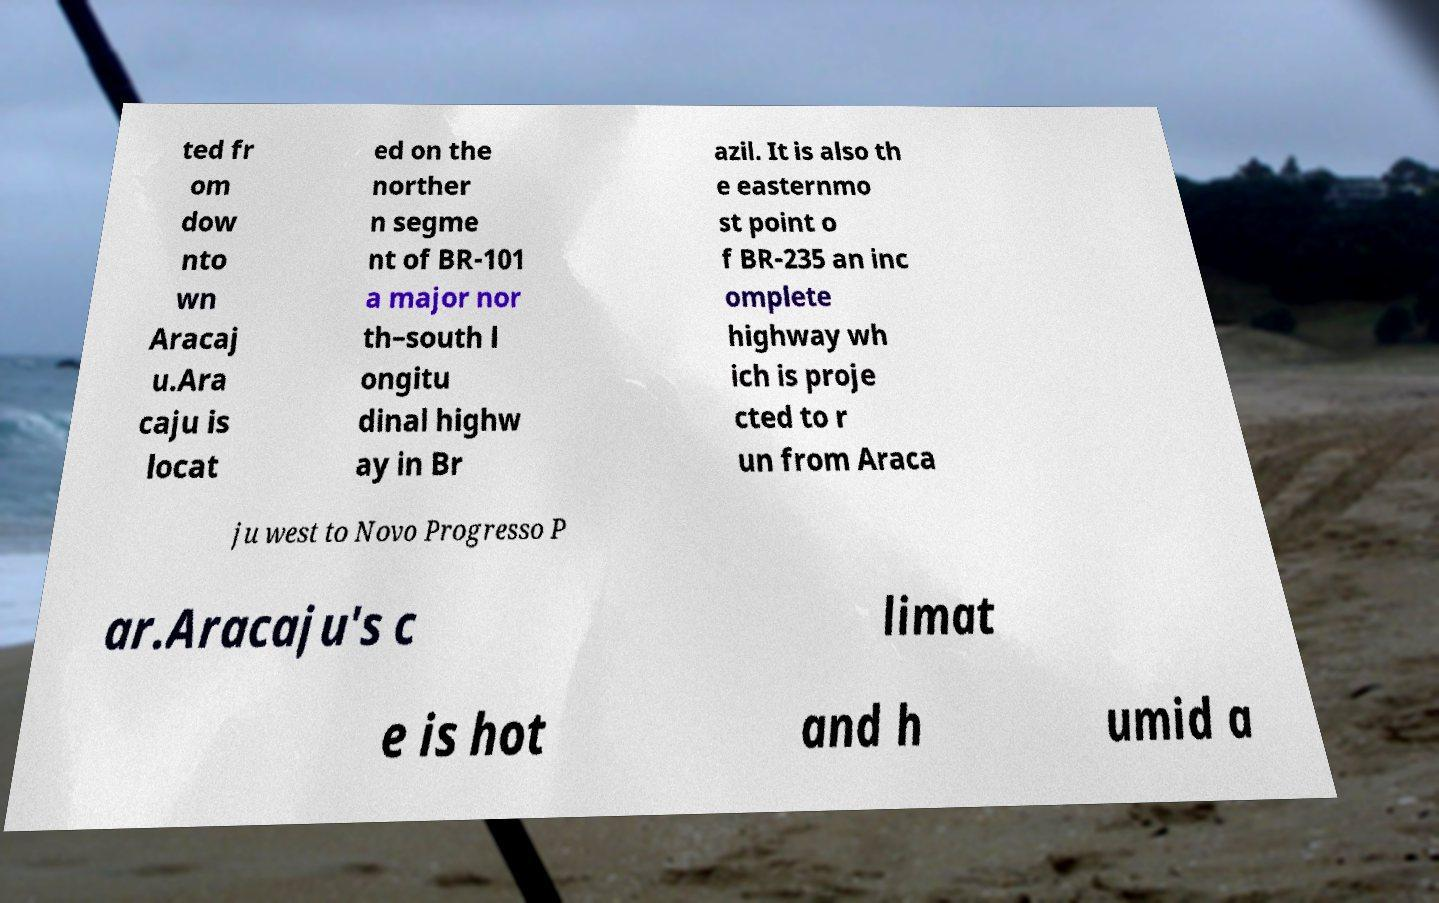What messages or text are displayed in this image? I need them in a readable, typed format. ted fr om dow nto wn Aracaj u.Ara caju is locat ed on the norther n segme nt of BR-101 a major nor th–south l ongitu dinal highw ay in Br azil. It is also th e easternmo st point o f BR-235 an inc omplete highway wh ich is proje cted to r un from Araca ju west to Novo Progresso P ar.Aracaju's c limat e is hot and h umid a 